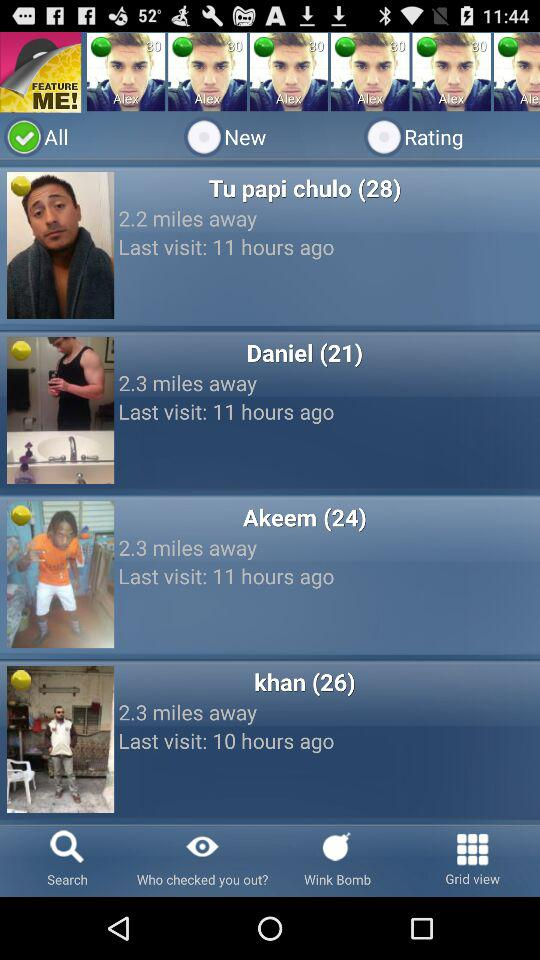What is the distance mentioned for Daniel? The distance is 2.3 miles. 